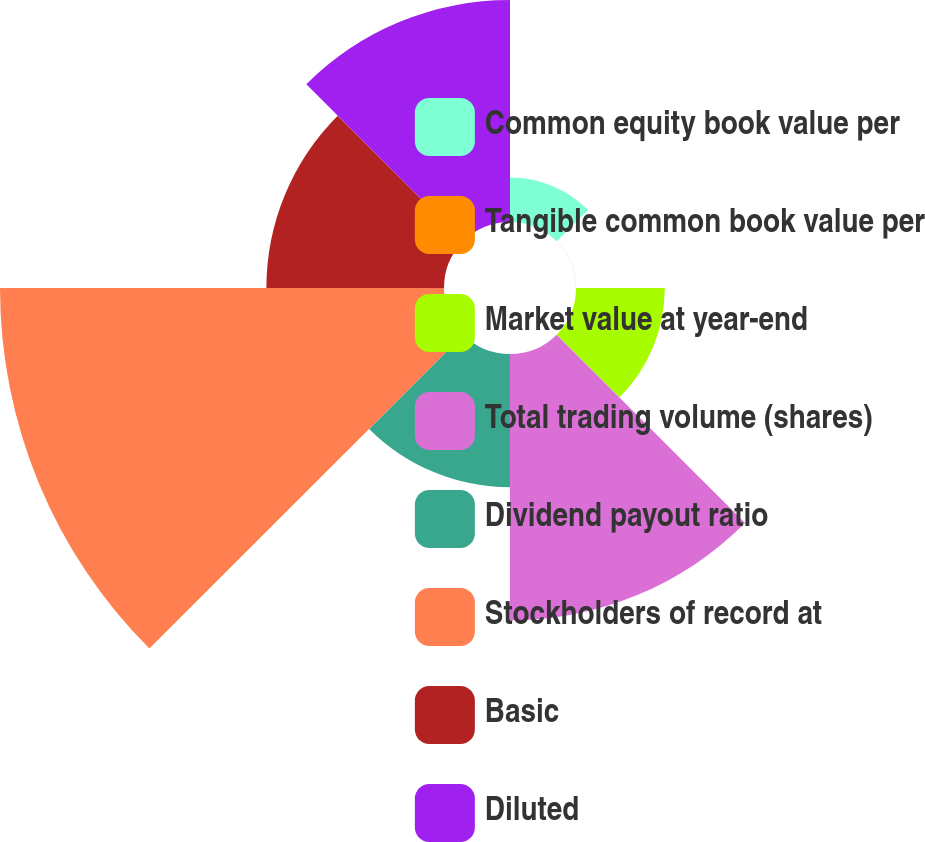Convert chart to OTSL. <chart><loc_0><loc_0><loc_500><loc_500><pie_chart><fcel>Common equity book value per<fcel>Tangible common book value per<fcel>Market value at year-end<fcel>Total trading volume (shares)<fcel>Dividend payout ratio<fcel>Stockholders of record at<fcel>Basic<fcel>Diluted<nl><fcel>3.23%<fcel>0.01%<fcel>6.45%<fcel>19.35%<fcel>9.68%<fcel>32.25%<fcel>12.9%<fcel>16.13%<nl></chart> 